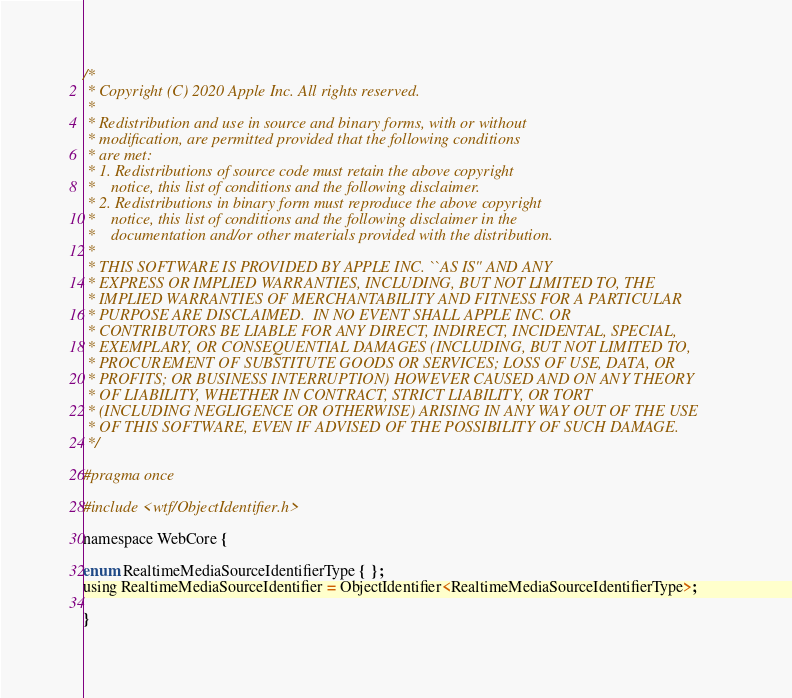<code> <loc_0><loc_0><loc_500><loc_500><_C_>/*
 * Copyright (C) 2020 Apple Inc. All rights reserved.
 *
 * Redistribution and use in source and binary forms, with or without
 * modification, are permitted provided that the following conditions
 * are met:
 * 1. Redistributions of source code must retain the above copyright
 *    notice, this list of conditions and the following disclaimer.
 * 2. Redistributions in binary form must reproduce the above copyright
 *    notice, this list of conditions and the following disclaimer in the
 *    documentation and/or other materials provided with the distribution.
 *
 * THIS SOFTWARE IS PROVIDED BY APPLE INC. ``AS IS'' AND ANY
 * EXPRESS OR IMPLIED WARRANTIES, INCLUDING, BUT NOT LIMITED TO, THE
 * IMPLIED WARRANTIES OF MERCHANTABILITY AND FITNESS FOR A PARTICULAR
 * PURPOSE ARE DISCLAIMED.  IN NO EVENT SHALL APPLE INC. OR
 * CONTRIBUTORS BE LIABLE FOR ANY DIRECT, INDIRECT, INCIDENTAL, SPECIAL,
 * EXEMPLARY, OR CONSEQUENTIAL DAMAGES (INCLUDING, BUT NOT LIMITED TO,
 * PROCUREMENT OF SUBSTITUTE GOODS OR SERVICES; LOSS OF USE, DATA, OR
 * PROFITS; OR BUSINESS INTERRUPTION) HOWEVER CAUSED AND ON ANY THEORY
 * OF LIABILITY, WHETHER IN CONTRACT, STRICT LIABILITY, OR TORT
 * (INCLUDING NEGLIGENCE OR OTHERWISE) ARISING IN ANY WAY OUT OF THE USE
 * OF THIS SOFTWARE, EVEN IF ADVISED OF THE POSSIBILITY OF SUCH DAMAGE.
 */

#pragma once

#include <wtf/ObjectIdentifier.h>

namespace WebCore {

enum RealtimeMediaSourceIdentifierType { };
using RealtimeMediaSourceIdentifier = ObjectIdentifier<RealtimeMediaSourceIdentifierType>;

}
</code> 